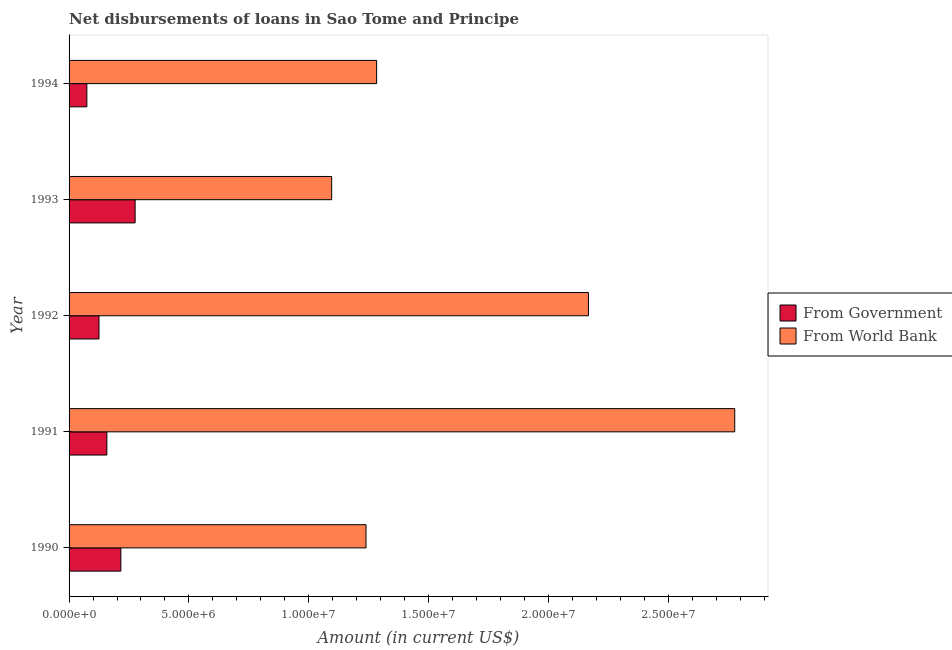How many different coloured bars are there?
Provide a short and direct response. 2. How many groups of bars are there?
Make the answer very short. 5. Are the number of bars on each tick of the Y-axis equal?
Make the answer very short. Yes. How many bars are there on the 5th tick from the bottom?
Offer a very short reply. 2. What is the net disbursements of loan from world bank in 1994?
Offer a very short reply. 1.28e+07. Across all years, what is the maximum net disbursements of loan from world bank?
Make the answer very short. 2.78e+07. Across all years, what is the minimum net disbursements of loan from government?
Provide a short and direct response. 7.42e+05. In which year was the net disbursements of loan from world bank minimum?
Your answer should be compact. 1993. What is the total net disbursements of loan from world bank in the graph?
Ensure brevity in your answer.  8.56e+07. What is the difference between the net disbursements of loan from government in 1990 and that in 1993?
Ensure brevity in your answer.  -5.95e+05. What is the difference between the net disbursements of loan from world bank in 1991 and the net disbursements of loan from government in 1990?
Your answer should be very brief. 2.56e+07. What is the average net disbursements of loan from world bank per year?
Your answer should be compact. 1.71e+07. In the year 1994, what is the difference between the net disbursements of loan from world bank and net disbursements of loan from government?
Ensure brevity in your answer.  1.21e+07. In how many years, is the net disbursements of loan from world bank greater than 28000000 US$?
Your answer should be compact. 0. What is the ratio of the net disbursements of loan from world bank in 1990 to that in 1994?
Your answer should be very brief. 0.96. What is the difference between the highest and the second highest net disbursements of loan from world bank?
Offer a terse response. 6.10e+06. What is the difference between the highest and the lowest net disbursements of loan from government?
Keep it short and to the point. 2.01e+06. In how many years, is the net disbursements of loan from government greater than the average net disbursements of loan from government taken over all years?
Your response must be concise. 2. What does the 1st bar from the top in 1990 represents?
Keep it short and to the point. From World Bank. What does the 2nd bar from the bottom in 1992 represents?
Your answer should be very brief. From World Bank. How many bars are there?
Provide a short and direct response. 10. Are the values on the major ticks of X-axis written in scientific E-notation?
Your answer should be compact. Yes. Does the graph contain grids?
Offer a terse response. No. How many legend labels are there?
Give a very brief answer. 2. What is the title of the graph?
Give a very brief answer. Net disbursements of loans in Sao Tome and Principe. Does "Tetanus" appear as one of the legend labels in the graph?
Make the answer very short. No. What is the label or title of the X-axis?
Make the answer very short. Amount (in current US$). What is the Amount (in current US$) of From Government in 1990?
Provide a short and direct response. 2.16e+06. What is the Amount (in current US$) in From World Bank in 1990?
Keep it short and to the point. 1.24e+07. What is the Amount (in current US$) in From Government in 1991?
Your response must be concise. 1.58e+06. What is the Amount (in current US$) in From World Bank in 1991?
Your response must be concise. 2.78e+07. What is the Amount (in current US$) in From Government in 1992?
Keep it short and to the point. 1.25e+06. What is the Amount (in current US$) in From World Bank in 1992?
Ensure brevity in your answer.  2.17e+07. What is the Amount (in current US$) in From Government in 1993?
Provide a succinct answer. 2.76e+06. What is the Amount (in current US$) in From World Bank in 1993?
Offer a very short reply. 1.10e+07. What is the Amount (in current US$) of From Government in 1994?
Your answer should be very brief. 7.42e+05. What is the Amount (in current US$) in From World Bank in 1994?
Your answer should be compact. 1.28e+07. Across all years, what is the maximum Amount (in current US$) in From Government?
Your answer should be very brief. 2.76e+06. Across all years, what is the maximum Amount (in current US$) in From World Bank?
Ensure brevity in your answer.  2.78e+07. Across all years, what is the minimum Amount (in current US$) of From Government?
Your response must be concise. 7.42e+05. Across all years, what is the minimum Amount (in current US$) of From World Bank?
Keep it short and to the point. 1.10e+07. What is the total Amount (in current US$) of From Government in the graph?
Ensure brevity in your answer.  8.48e+06. What is the total Amount (in current US$) of From World Bank in the graph?
Give a very brief answer. 8.56e+07. What is the difference between the Amount (in current US$) of From Government in 1990 and that in 1991?
Your answer should be very brief. 5.84e+05. What is the difference between the Amount (in current US$) of From World Bank in 1990 and that in 1991?
Offer a terse response. -1.54e+07. What is the difference between the Amount (in current US$) in From Government in 1990 and that in 1992?
Your answer should be compact. 9.12e+05. What is the difference between the Amount (in current US$) in From World Bank in 1990 and that in 1992?
Provide a short and direct response. -9.28e+06. What is the difference between the Amount (in current US$) of From Government in 1990 and that in 1993?
Offer a very short reply. -5.95e+05. What is the difference between the Amount (in current US$) of From World Bank in 1990 and that in 1993?
Keep it short and to the point. 1.43e+06. What is the difference between the Amount (in current US$) of From Government in 1990 and that in 1994?
Keep it short and to the point. 1.42e+06. What is the difference between the Amount (in current US$) in From World Bank in 1990 and that in 1994?
Make the answer very short. -4.44e+05. What is the difference between the Amount (in current US$) of From Government in 1991 and that in 1992?
Ensure brevity in your answer.  3.28e+05. What is the difference between the Amount (in current US$) of From World Bank in 1991 and that in 1992?
Your answer should be very brief. 6.10e+06. What is the difference between the Amount (in current US$) of From Government in 1991 and that in 1993?
Offer a very short reply. -1.18e+06. What is the difference between the Amount (in current US$) of From World Bank in 1991 and that in 1993?
Ensure brevity in your answer.  1.68e+07. What is the difference between the Amount (in current US$) in From Government in 1991 and that in 1994?
Offer a terse response. 8.35e+05. What is the difference between the Amount (in current US$) in From World Bank in 1991 and that in 1994?
Your response must be concise. 1.49e+07. What is the difference between the Amount (in current US$) of From Government in 1992 and that in 1993?
Provide a short and direct response. -1.51e+06. What is the difference between the Amount (in current US$) of From World Bank in 1992 and that in 1993?
Provide a succinct answer. 1.07e+07. What is the difference between the Amount (in current US$) of From Government in 1992 and that in 1994?
Your response must be concise. 5.07e+05. What is the difference between the Amount (in current US$) in From World Bank in 1992 and that in 1994?
Your response must be concise. 8.84e+06. What is the difference between the Amount (in current US$) of From Government in 1993 and that in 1994?
Keep it short and to the point. 2.01e+06. What is the difference between the Amount (in current US$) of From World Bank in 1993 and that in 1994?
Offer a terse response. -1.88e+06. What is the difference between the Amount (in current US$) of From Government in 1990 and the Amount (in current US$) of From World Bank in 1991?
Your response must be concise. -2.56e+07. What is the difference between the Amount (in current US$) in From Government in 1990 and the Amount (in current US$) in From World Bank in 1992?
Ensure brevity in your answer.  -1.95e+07. What is the difference between the Amount (in current US$) of From Government in 1990 and the Amount (in current US$) of From World Bank in 1993?
Give a very brief answer. -8.80e+06. What is the difference between the Amount (in current US$) in From Government in 1990 and the Amount (in current US$) in From World Bank in 1994?
Offer a terse response. -1.07e+07. What is the difference between the Amount (in current US$) in From Government in 1991 and the Amount (in current US$) in From World Bank in 1992?
Ensure brevity in your answer.  -2.01e+07. What is the difference between the Amount (in current US$) of From Government in 1991 and the Amount (in current US$) of From World Bank in 1993?
Give a very brief answer. -9.38e+06. What is the difference between the Amount (in current US$) of From Government in 1991 and the Amount (in current US$) of From World Bank in 1994?
Ensure brevity in your answer.  -1.13e+07. What is the difference between the Amount (in current US$) of From Government in 1992 and the Amount (in current US$) of From World Bank in 1993?
Give a very brief answer. -9.71e+06. What is the difference between the Amount (in current US$) of From Government in 1992 and the Amount (in current US$) of From World Bank in 1994?
Provide a short and direct response. -1.16e+07. What is the difference between the Amount (in current US$) in From Government in 1993 and the Amount (in current US$) in From World Bank in 1994?
Offer a terse response. -1.01e+07. What is the average Amount (in current US$) of From Government per year?
Your response must be concise. 1.70e+06. What is the average Amount (in current US$) of From World Bank per year?
Offer a terse response. 1.71e+07. In the year 1990, what is the difference between the Amount (in current US$) in From Government and Amount (in current US$) in From World Bank?
Keep it short and to the point. -1.02e+07. In the year 1991, what is the difference between the Amount (in current US$) in From Government and Amount (in current US$) in From World Bank?
Your answer should be very brief. -2.62e+07. In the year 1992, what is the difference between the Amount (in current US$) of From Government and Amount (in current US$) of From World Bank?
Keep it short and to the point. -2.04e+07. In the year 1993, what is the difference between the Amount (in current US$) in From Government and Amount (in current US$) in From World Bank?
Your answer should be very brief. -8.20e+06. In the year 1994, what is the difference between the Amount (in current US$) of From Government and Amount (in current US$) of From World Bank?
Your response must be concise. -1.21e+07. What is the ratio of the Amount (in current US$) of From Government in 1990 to that in 1991?
Your response must be concise. 1.37. What is the ratio of the Amount (in current US$) of From World Bank in 1990 to that in 1991?
Your answer should be very brief. 0.45. What is the ratio of the Amount (in current US$) of From Government in 1990 to that in 1992?
Offer a terse response. 1.73. What is the ratio of the Amount (in current US$) of From World Bank in 1990 to that in 1992?
Ensure brevity in your answer.  0.57. What is the ratio of the Amount (in current US$) in From Government in 1990 to that in 1993?
Provide a succinct answer. 0.78. What is the ratio of the Amount (in current US$) of From World Bank in 1990 to that in 1993?
Your answer should be very brief. 1.13. What is the ratio of the Amount (in current US$) in From Government in 1990 to that in 1994?
Keep it short and to the point. 2.91. What is the ratio of the Amount (in current US$) in From World Bank in 1990 to that in 1994?
Your response must be concise. 0.97. What is the ratio of the Amount (in current US$) of From Government in 1991 to that in 1992?
Keep it short and to the point. 1.26. What is the ratio of the Amount (in current US$) in From World Bank in 1991 to that in 1992?
Provide a short and direct response. 1.28. What is the ratio of the Amount (in current US$) of From Government in 1991 to that in 1993?
Ensure brevity in your answer.  0.57. What is the ratio of the Amount (in current US$) of From World Bank in 1991 to that in 1993?
Offer a very short reply. 2.54. What is the ratio of the Amount (in current US$) in From Government in 1991 to that in 1994?
Keep it short and to the point. 2.13. What is the ratio of the Amount (in current US$) in From World Bank in 1991 to that in 1994?
Offer a terse response. 2.16. What is the ratio of the Amount (in current US$) in From Government in 1992 to that in 1993?
Offer a very short reply. 0.45. What is the ratio of the Amount (in current US$) in From World Bank in 1992 to that in 1993?
Offer a terse response. 1.98. What is the ratio of the Amount (in current US$) of From Government in 1992 to that in 1994?
Your response must be concise. 1.68. What is the ratio of the Amount (in current US$) of From World Bank in 1992 to that in 1994?
Your response must be concise. 1.69. What is the ratio of the Amount (in current US$) of From Government in 1993 to that in 1994?
Ensure brevity in your answer.  3.71. What is the ratio of the Amount (in current US$) in From World Bank in 1993 to that in 1994?
Your response must be concise. 0.85. What is the difference between the highest and the second highest Amount (in current US$) of From Government?
Your response must be concise. 5.95e+05. What is the difference between the highest and the second highest Amount (in current US$) in From World Bank?
Make the answer very short. 6.10e+06. What is the difference between the highest and the lowest Amount (in current US$) in From Government?
Provide a short and direct response. 2.01e+06. What is the difference between the highest and the lowest Amount (in current US$) in From World Bank?
Make the answer very short. 1.68e+07. 